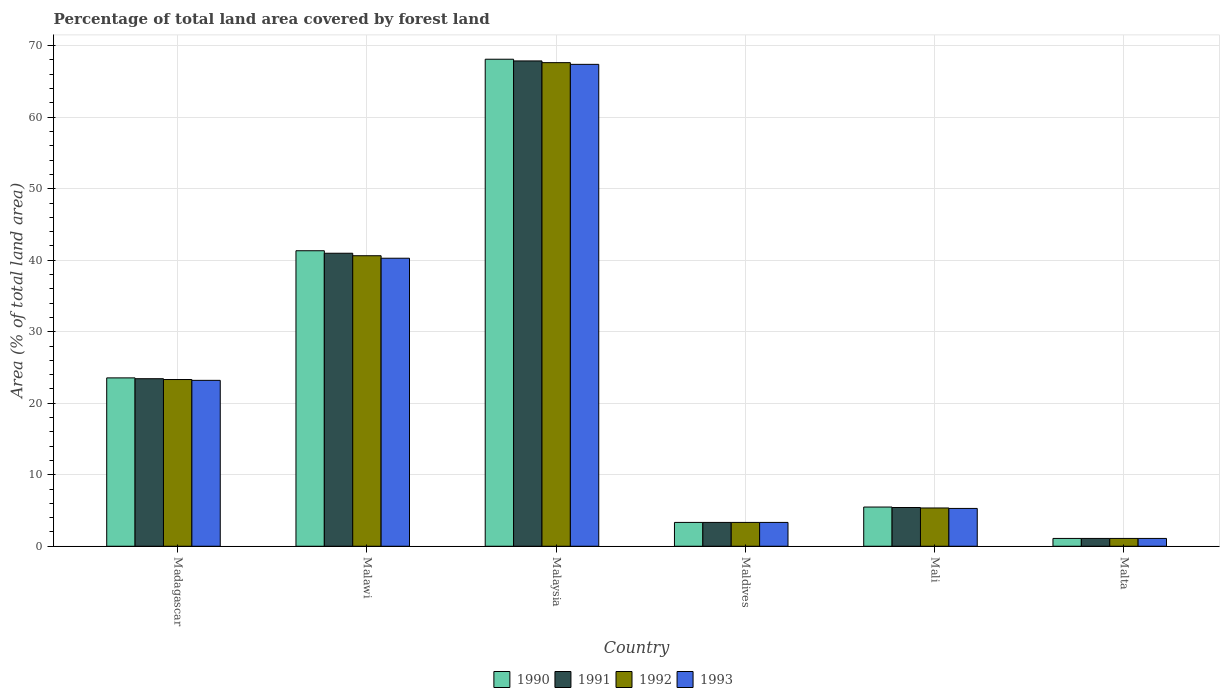How many different coloured bars are there?
Provide a short and direct response. 4. Are the number of bars on each tick of the X-axis equal?
Your answer should be compact. Yes. How many bars are there on the 4th tick from the left?
Keep it short and to the point. 4. What is the label of the 1st group of bars from the left?
Give a very brief answer. Madagascar. In how many cases, is the number of bars for a given country not equal to the number of legend labels?
Make the answer very short. 0. What is the percentage of forest land in 1990 in Malaysia?
Your answer should be compact. 68.11. Across all countries, what is the maximum percentage of forest land in 1993?
Offer a very short reply. 67.39. Across all countries, what is the minimum percentage of forest land in 1990?
Offer a terse response. 1.09. In which country was the percentage of forest land in 1993 maximum?
Provide a short and direct response. Malaysia. In which country was the percentage of forest land in 1990 minimum?
Your answer should be compact. Malta. What is the total percentage of forest land in 1992 in the graph?
Provide a succinct answer. 141.35. What is the difference between the percentage of forest land in 1992 in Malawi and that in Malaysia?
Offer a very short reply. -27. What is the difference between the percentage of forest land in 1991 in Madagascar and the percentage of forest land in 1993 in Malaysia?
Your answer should be compact. -43.96. What is the average percentage of forest land in 1990 per country?
Provide a short and direct response. 23.81. What is the difference between the percentage of forest land of/in 1990 and percentage of forest land of/in 1993 in Mali?
Offer a very short reply. 0.19. In how many countries, is the percentage of forest land in 1990 greater than 30 %?
Ensure brevity in your answer.  2. What is the ratio of the percentage of forest land in 1990 in Madagascar to that in Mali?
Provide a short and direct response. 4.29. What is the difference between the highest and the second highest percentage of forest land in 1993?
Offer a very short reply. -27.11. What is the difference between the highest and the lowest percentage of forest land in 1992?
Provide a succinct answer. 66.53. Is the sum of the percentage of forest land in 1990 in Malawi and Malta greater than the maximum percentage of forest land in 1992 across all countries?
Provide a succinct answer. No. What does the 2nd bar from the left in Malawi represents?
Offer a very short reply. 1991. How many countries are there in the graph?
Give a very brief answer. 6. What is the difference between two consecutive major ticks on the Y-axis?
Your answer should be compact. 10. Are the values on the major ticks of Y-axis written in scientific E-notation?
Offer a very short reply. No. Does the graph contain grids?
Provide a succinct answer. Yes. Where does the legend appear in the graph?
Provide a short and direct response. Bottom center. How are the legend labels stacked?
Ensure brevity in your answer.  Horizontal. What is the title of the graph?
Make the answer very short. Percentage of total land area covered by forest land. What is the label or title of the Y-axis?
Your answer should be very brief. Area (% of total land area). What is the Area (% of total land area) in 1990 in Madagascar?
Provide a succinct answer. 23.54. What is the Area (% of total land area) in 1991 in Madagascar?
Provide a short and direct response. 23.43. What is the Area (% of total land area) of 1992 in Madagascar?
Provide a short and direct response. 23.31. What is the Area (% of total land area) of 1993 in Madagascar?
Ensure brevity in your answer.  23.2. What is the Area (% of total land area) in 1990 in Malawi?
Offer a very short reply. 41.32. What is the Area (% of total land area) of 1991 in Malawi?
Make the answer very short. 40.97. What is the Area (% of total land area) in 1992 in Malawi?
Make the answer very short. 40.63. What is the Area (% of total land area) in 1993 in Malawi?
Give a very brief answer. 40.28. What is the Area (% of total land area) of 1990 in Malaysia?
Give a very brief answer. 68.11. What is the Area (% of total land area) of 1991 in Malaysia?
Make the answer very short. 67.87. What is the Area (% of total land area) of 1992 in Malaysia?
Give a very brief answer. 67.63. What is the Area (% of total land area) of 1993 in Malaysia?
Your answer should be very brief. 67.39. What is the Area (% of total land area) of 1990 in Maldives?
Offer a very short reply. 3.33. What is the Area (% of total land area) of 1991 in Maldives?
Keep it short and to the point. 3.33. What is the Area (% of total land area) of 1992 in Maldives?
Provide a short and direct response. 3.33. What is the Area (% of total land area) in 1993 in Maldives?
Keep it short and to the point. 3.33. What is the Area (% of total land area) in 1990 in Mali?
Your answer should be compact. 5.48. What is the Area (% of total land area) of 1991 in Mali?
Ensure brevity in your answer.  5.42. What is the Area (% of total land area) in 1992 in Mali?
Offer a terse response. 5.35. What is the Area (% of total land area) in 1993 in Mali?
Provide a short and direct response. 5.29. What is the Area (% of total land area) in 1990 in Malta?
Your answer should be compact. 1.09. What is the Area (% of total land area) in 1991 in Malta?
Offer a very short reply. 1.09. What is the Area (% of total land area) of 1992 in Malta?
Offer a terse response. 1.09. What is the Area (% of total land area) in 1993 in Malta?
Your answer should be compact. 1.09. Across all countries, what is the maximum Area (% of total land area) in 1990?
Your answer should be very brief. 68.11. Across all countries, what is the maximum Area (% of total land area) in 1991?
Your answer should be very brief. 67.87. Across all countries, what is the maximum Area (% of total land area) in 1992?
Offer a terse response. 67.63. Across all countries, what is the maximum Area (% of total land area) of 1993?
Offer a terse response. 67.39. Across all countries, what is the minimum Area (% of total land area) in 1990?
Offer a terse response. 1.09. Across all countries, what is the minimum Area (% of total land area) in 1991?
Offer a terse response. 1.09. Across all countries, what is the minimum Area (% of total land area) of 1992?
Make the answer very short. 1.09. Across all countries, what is the minimum Area (% of total land area) of 1993?
Offer a terse response. 1.09. What is the total Area (% of total land area) in 1990 in the graph?
Make the answer very short. 142.88. What is the total Area (% of total land area) of 1991 in the graph?
Provide a succinct answer. 142.12. What is the total Area (% of total land area) of 1992 in the graph?
Make the answer very short. 141.35. What is the total Area (% of total land area) in 1993 in the graph?
Your response must be concise. 140.58. What is the difference between the Area (% of total land area) in 1990 in Madagascar and that in Malawi?
Give a very brief answer. -17.78. What is the difference between the Area (% of total land area) of 1991 in Madagascar and that in Malawi?
Your answer should be compact. -17.55. What is the difference between the Area (% of total land area) of 1992 in Madagascar and that in Malawi?
Your response must be concise. -17.31. What is the difference between the Area (% of total land area) of 1993 in Madagascar and that in Malawi?
Your answer should be very brief. -17.08. What is the difference between the Area (% of total land area) of 1990 in Madagascar and that in Malaysia?
Offer a very short reply. -44.56. What is the difference between the Area (% of total land area) of 1991 in Madagascar and that in Malaysia?
Offer a very short reply. -44.44. What is the difference between the Area (% of total land area) of 1992 in Madagascar and that in Malaysia?
Your response must be concise. -44.31. What is the difference between the Area (% of total land area) of 1993 in Madagascar and that in Malaysia?
Ensure brevity in your answer.  -44.19. What is the difference between the Area (% of total land area) in 1990 in Madagascar and that in Maldives?
Offer a very short reply. 20.21. What is the difference between the Area (% of total land area) of 1991 in Madagascar and that in Maldives?
Make the answer very short. 20.1. What is the difference between the Area (% of total land area) in 1992 in Madagascar and that in Maldives?
Your response must be concise. 19.98. What is the difference between the Area (% of total land area) in 1993 in Madagascar and that in Maldives?
Your answer should be compact. 19.87. What is the difference between the Area (% of total land area) of 1990 in Madagascar and that in Mali?
Offer a very short reply. 18.06. What is the difference between the Area (% of total land area) of 1991 in Madagascar and that in Mali?
Give a very brief answer. 18.01. What is the difference between the Area (% of total land area) in 1992 in Madagascar and that in Mali?
Give a very brief answer. 17.96. What is the difference between the Area (% of total land area) of 1993 in Madagascar and that in Mali?
Give a very brief answer. 17.91. What is the difference between the Area (% of total land area) of 1990 in Madagascar and that in Malta?
Make the answer very short. 22.45. What is the difference between the Area (% of total land area) of 1991 in Madagascar and that in Malta?
Offer a terse response. 22.34. What is the difference between the Area (% of total land area) in 1992 in Madagascar and that in Malta?
Make the answer very short. 22.22. What is the difference between the Area (% of total land area) of 1993 in Madagascar and that in Malta?
Make the answer very short. 22.11. What is the difference between the Area (% of total land area) in 1990 in Malawi and that in Malaysia?
Your answer should be compact. -26.78. What is the difference between the Area (% of total land area) of 1991 in Malawi and that in Malaysia?
Your answer should be very brief. -26.89. What is the difference between the Area (% of total land area) in 1992 in Malawi and that in Malaysia?
Offer a very short reply. -27. What is the difference between the Area (% of total land area) in 1993 in Malawi and that in Malaysia?
Offer a very short reply. -27.11. What is the difference between the Area (% of total land area) of 1990 in Malawi and that in Maldives?
Ensure brevity in your answer.  37.99. What is the difference between the Area (% of total land area) in 1991 in Malawi and that in Maldives?
Make the answer very short. 37.64. What is the difference between the Area (% of total land area) of 1992 in Malawi and that in Maldives?
Offer a very short reply. 37.29. What is the difference between the Area (% of total land area) of 1993 in Malawi and that in Maldives?
Your answer should be very brief. 36.94. What is the difference between the Area (% of total land area) in 1990 in Malawi and that in Mali?
Give a very brief answer. 35.84. What is the difference between the Area (% of total land area) of 1991 in Malawi and that in Mali?
Make the answer very short. 35.56. What is the difference between the Area (% of total land area) of 1992 in Malawi and that in Mali?
Your response must be concise. 35.27. What is the difference between the Area (% of total land area) of 1993 in Malawi and that in Mali?
Offer a terse response. 34.99. What is the difference between the Area (% of total land area) of 1990 in Malawi and that in Malta?
Offer a terse response. 40.23. What is the difference between the Area (% of total land area) in 1991 in Malawi and that in Malta?
Keep it short and to the point. 39.88. What is the difference between the Area (% of total land area) of 1992 in Malawi and that in Malta?
Give a very brief answer. 39.53. What is the difference between the Area (% of total land area) of 1993 in Malawi and that in Malta?
Your response must be concise. 39.18. What is the difference between the Area (% of total land area) in 1990 in Malaysia and that in Maldives?
Offer a terse response. 64.77. What is the difference between the Area (% of total land area) of 1991 in Malaysia and that in Maldives?
Keep it short and to the point. 64.53. What is the difference between the Area (% of total land area) in 1992 in Malaysia and that in Maldives?
Make the answer very short. 64.29. What is the difference between the Area (% of total land area) of 1993 in Malaysia and that in Maldives?
Offer a very short reply. 64.06. What is the difference between the Area (% of total land area) in 1990 in Malaysia and that in Mali?
Ensure brevity in your answer.  62.62. What is the difference between the Area (% of total land area) in 1991 in Malaysia and that in Mali?
Offer a very short reply. 62.45. What is the difference between the Area (% of total land area) in 1992 in Malaysia and that in Mali?
Provide a short and direct response. 62.27. What is the difference between the Area (% of total land area) in 1993 in Malaysia and that in Mali?
Give a very brief answer. 62.1. What is the difference between the Area (% of total land area) in 1990 in Malaysia and that in Malta?
Your response must be concise. 67.01. What is the difference between the Area (% of total land area) in 1991 in Malaysia and that in Malta?
Make the answer very short. 66.77. What is the difference between the Area (% of total land area) of 1992 in Malaysia and that in Malta?
Give a very brief answer. 66.53. What is the difference between the Area (% of total land area) of 1993 in Malaysia and that in Malta?
Your answer should be very brief. 66.29. What is the difference between the Area (% of total land area) in 1990 in Maldives and that in Mali?
Provide a short and direct response. -2.15. What is the difference between the Area (% of total land area) in 1991 in Maldives and that in Mali?
Make the answer very short. -2.08. What is the difference between the Area (% of total land area) of 1992 in Maldives and that in Mali?
Keep it short and to the point. -2.02. What is the difference between the Area (% of total land area) of 1993 in Maldives and that in Mali?
Give a very brief answer. -1.96. What is the difference between the Area (% of total land area) in 1990 in Maldives and that in Malta?
Offer a very short reply. 2.24. What is the difference between the Area (% of total land area) of 1991 in Maldives and that in Malta?
Make the answer very short. 2.24. What is the difference between the Area (% of total land area) in 1992 in Maldives and that in Malta?
Your response must be concise. 2.24. What is the difference between the Area (% of total land area) of 1993 in Maldives and that in Malta?
Make the answer very short. 2.24. What is the difference between the Area (% of total land area) of 1990 in Mali and that in Malta?
Give a very brief answer. 4.39. What is the difference between the Area (% of total land area) in 1991 in Mali and that in Malta?
Give a very brief answer. 4.32. What is the difference between the Area (% of total land area) of 1992 in Mali and that in Malta?
Keep it short and to the point. 4.26. What is the difference between the Area (% of total land area) of 1993 in Mali and that in Malta?
Offer a very short reply. 4.19. What is the difference between the Area (% of total land area) of 1990 in Madagascar and the Area (% of total land area) of 1991 in Malawi?
Offer a terse response. -17.43. What is the difference between the Area (% of total land area) of 1990 in Madagascar and the Area (% of total land area) of 1992 in Malawi?
Your response must be concise. -17.08. What is the difference between the Area (% of total land area) in 1990 in Madagascar and the Area (% of total land area) in 1993 in Malawi?
Provide a succinct answer. -16.73. What is the difference between the Area (% of total land area) in 1991 in Madagascar and the Area (% of total land area) in 1992 in Malawi?
Your response must be concise. -17.2. What is the difference between the Area (% of total land area) of 1991 in Madagascar and the Area (% of total land area) of 1993 in Malawi?
Ensure brevity in your answer.  -16.85. What is the difference between the Area (% of total land area) in 1992 in Madagascar and the Area (% of total land area) in 1993 in Malawi?
Your answer should be very brief. -16.96. What is the difference between the Area (% of total land area) in 1990 in Madagascar and the Area (% of total land area) in 1991 in Malaysia?
Your answer should be compact. -44.32. What is the difference between the Area (% of total land area) of 1990 in Madagascar and the Area (% of total land area) of 1992 in Malaysia?
Keep it short and to the point. -44.08. What is the difference between the Area (% of total land area) of 1990 in Madagascar and the Area (% of total land area) of 1993 in Malaysia?
Your answer should be very brief. -43.84. What is the difference between the Area (% of total land area) in 1991 in Madagascar and the Area (% of total land area) in 1992 in Malaysia?
Your response must be concise. -44.2. What is the difference between the Area (% of total land area) of 1991 in Madagascar and the Area (% of total land area) of 1993 in Malaysia?
Your answer should be very brief. -43.96. What is the difference between the Area (% of total land area) of 1992 in Madagascar and the Area (% of total land area) of 1993 in Malaysia?
Keep it short and to the point. -44.07. What is the difference between the Area (% of total land area) in 1990 in Madagascar and the Area (% of total land area) in 1991 in Maldives?
Give a very brief answer. 20.21. What is the difference between the Area (% of total land area) of 1990 in Madagascar and the Area (% of total land area) of 1992 in Maldives?
Provide a short and direct response. 20.21. What is the difference between the Area (% of total land area) in 1990 in Madagascar and the Area (% of total land area) in 1993 in Maldives?
Your response must be concise. 20.21. What is the difference between the Area (% of total land area) in 1991 in Madagascar and the Area (% of total land area) in 1992 in Maldives?
Keep it short and to the point. 20.1. What is the difference between the Area (% of total land area) of 1991 in Madagascar and the Area (% of total land area) of 1993 in Maldives?
Keep it short and to the point. 20.1. What is the difference between the Area (% of total land area) of 1992 in Madagascar and the Area (% of total land area) of 1993 in Maldives?
Keep it short and to the point. 19.98. What is the difference between the Area (% of total land area) of 1990 in Madagascar and the Area (% of total land area) of 1991 in Mali?
Make the answer very short. 18.13. What is the difference between the Area (% of total land area) of 1990 in Madagascar and the Area (% of total land area) of 1992 in Mali?
Your response must be concise. 18.19. What is the difference between the Area (% of total land area) of 1990 in Madagascar and the Area (% of total land area) of 1993 in Mali?
Keep it short and to the point. 18.26. What is the difference between the Area (% of total land area) in 1991 in Madagascar and the Area (% of total land area) in 1992 in Mali?
Provide a succinct answer. 18.08. What is the difference between the Area (% of total land area) of 1991 in Madagascar and the Area (% of total land area) of 1993 in Mali?
Give a very brief answer. 18.14. What is the difference between the Area (% of total land area) of 1992 in Madagascar and the Area (% of total land area) of 1993 in Mali?
Your answer should be very brief. 18.03. What is the difference between the Area (% of total land area) of 1990 in Madagascar and the Area (% of total land area) of 1991 in Malta?
Provide a short and direct response. 22.45. What is the difference between the Area (% of total land area) in 1990 in Madagascar and the Area (% of total land area) in 1992 in Malta?
Give a very brief answer. 22.45. What is the difference between the Area (% of total land area) of 1990 in Madagascar and the Area (% of total land area) of 1993 in Malta?
Your response must be concise. 22.45. What is the difference between the Area (% of total land area) in 1991 in Madagascar and the Area (% of total land area) in 1992 in Malta?
Your answer should be compact. 22.34. What is the difference between the Area (% of total land area) in 1991 in Madagascar and the Area (% of total land area) in 1993 in Malta?
Ensure brevity in your answer.  22.34. What is the difference between the Area (% of total land area) in 1992 in Madagascar and the Area (% of total land area) in 1993 in Malta?
Your answer should be very brief. 22.22. What is the difference between the Area (% of total land area) in 1990 in Malawi and the Area (% of total land area) in 1991 in Malaysia?
Provide a short and direct response. -26.54. What is the difference between the Area (% of total land area) in 1990 in Malawi and the Area (% of total land area) in 1992 in Malaysia?
Your answer should be compact. -26.3. What is the difference between the Area (% of total land area) of 1990 in Malawi and the Area (% of total land area) of 1993 in Malaysia?
Offer a terse response. -26.06. What is the difference between the Area (% of total land area) in 1991 in Malawi and the Area (% of total land area) in 1992 in Malaysia?
Your answer should be very brief. -26.65. What is the difference between the Area (% of total land area) of 1991 in Malawi and the Area (% of total land area) of 1993 in Malaysia?
Your response must be concise. -26.41. What is the difference between the Area (% of total land area) in 1992 in Malawi and the Area (% of total land area) in 1993 in Malaysia?
Ensure brevity in your answer.  -26.76. What is the difference between the Area (% of total land area) of 1990 in Malawi and the Area (% of total land area) of 1991 in Maldives?
Offer a very short reply. 37.99. What is the difference between the Area (% of total land area) of 1990 in Malawi and the Area (% of total land area) of 1992 in Maldives?
Provide a short and direct response. 37.99. What is the difference between the Area (% of total land area) in 1990 in Malawi and the Area (% of total land area) in 1993 in Maldives?
Keep it short and to the point. 37.99. What is the difference between the Area (% of total land area) in 1991 in Malawi and the Area (% of total land area) in 1992 in Maldives?
Ensure brevity in your answer.  37.64. What is the difference between the Area (% of total land area) of 1991 in Malawi and the Area (% of total land area) of 1993 in Maldives?
Your response must be concise. 37.64. What is the difference between the Area (% of total land area) in 1992 in Malawi and the Area (% of total land area) in 1993 in Maldives?
Give a very brief answer. 37.29. What is the difference between the Area (% of total land area) of 1990 in Malawi and the Area (% of total land area) of 1991 in Mali?
Offer a terse response. 35.91. What is the difference between the Area (% of total land area) in 1990 in Malawi and the Area (% of total land area) in 1992 in Mali?
Your answer should be very brief. 35.97. What is the difference between the Area (% of total land area) of 1990 in Malawi and the Area (% of total land area) of 1993 in Mali?
Keep it short and to the point. 36.04. What is the difference between the Area (% of total land area) of 1991 in Malawi and the Area (% of total land area) of 1992 in Mali?
Your response must be concise. 35.62. What is the difference between the Area (% of total land area) in 1991 in Malawi and the Area (% of total land area) in 1993 in Mali?
Offer a very short reply. 35.69. What is the difference between the Area (% of total land area) of 1992 in Malawi and the Area (% of total land area) of 1993 in Mali?
Provide a succinct answer. 35.34. What is the difference between the Area (% of total land area) in 1990 in Malawi and the Area (% of total land area) in 1991 in Malta?
Offer a very short reply. 40.23. What is the difference between the Area (% of total land area) of 1990 in Malawi and the Area (% of total land area) of 1992 in Malta?
Keep it short and to the point. 40.23. What is the difference between the Area (% of total land area) of 1990 in Malawi and the Area (% of total land area) of 1993 in Malta?
Make the answer very short. 40.23. What is the difference between the Area (% of total land area) of 1991 in Malawi and the Area (% of total land area) of 1992 in Malta?
Give a very brief answer. 39.88. What is the difference between the Area (% of total land area) of 1991 in Malawi and the Area (% of total land area) of 1993 in Malta?
Offer a very short reply. 39.88. What is the difference between the Area (% of total land area) in 1992 in Malawi and the Area (% of total land area) in 1993 in Malta?
Your response must be concise. 39.53. What is the difference between the Area (% of total land area) of 1990 in Malaysia and the Area (% of total land area) of 1991 in Maldives?
Make the answer very short. 64.77. What is the difference between the Area (% of total land area) of 1990 in Malaysia and the Area (% of total land area) of 1992 in Maldives?
Give a very brief answer. 64.77. What is the difference between the Area (% of total land area) in 1990 in Malaysia and the Area (% of total land area) in 1993 in Maldives?
Your answer should be compact. 64.77. What is the difference between the Area (% of total land area) of 1991 in Malaysia and the Area (% of total land area) of 1992 in Maldives?
Keep it short and to the point. 64.53. What is the difference between the Area (% of total land area) in 1991 in Malaysia and the Area (% of total land area) in 1993 in Maldives?
Your answer should be very brief. 64.53. What is the difference between the Area (% of total land area) in 1992 in Malaysia and the Area (% of total land area) in 1993 in Maldives?
Your response must be concise. 64.29. What is the difference between the Area (% of total land area) of 1990 in Malaysia and the Area (% of total land area) of 1991 in Mali?
Keep it short and to the point. 62.69. What is the difference between the Area (% of total land area) in 1990 in Malaysia and the Area (% of total land area) in 1992 in Mali?
Keep it short and to the point. 62.75. What is the difference between the Area (% of total land area) in 1990 in Malaysia and the Area (% of total land area) in 1993 in Mali?
Provide a short and direct response. 62.82. What is the difference between the Area (% of total land area) in 1991 in Malaysia and the Area (% of total land area) in 1992 in Mali?
Give a very brief answer. 62.51. What is the difference between the Area (% of total land area) in 1991 in Malaysia and the Area (% of total land area) in 1993 in Mali?
Offer a very short reply. 62.58. What is the difference between the Area (% of total land area) in 1992 in Malaysia and the Area (% of total land area) in 1993 in Mali?
Make the answer very short. 62.34. What is the difference between the Area (% of total land area) in 1990 in Malaysia and the Area (% of total land area) in 1991 in Malta?
Provide a succinct answer. 67.01. What is the difference between the Area (% of total land area) in 1990 in Malaysia and the Area (% of total land area) in 1992 in Malta?
Your answer should be very brief. 67.01. What is the difference between the Area (% of total land area) of 1990 in Malaysia and the Area (% of total land area) of 1993 in Malta?
Provide a succinct answer. 67.01. What is the difference between the Area (% of total land area) of 1991 in Malaysia and the Area (% of total land area) of 1992 in Malta?
Your answer should be compact. 66.77. What is the difference between the Area (% of total land area) of 1991 in Malaysia and the Area (% of total land area) of 1993 in Malta?
Provide a short and direct response. 66.77. What is the difference between the Area (% of total land area) of 1992 in Malaysia and the Area (% of total land area) of 1993 in Malta?
Keep it short and to the point. 66.53. What is the difference between the Area (% of total land area) of 1990 in Maldives and the Area (% of total land area) of 1991 in Mali?
Offer a very short reply. -2.08. What is the difference between the Area (% of total land area) in 1990 in Maldives and the Area (% of total land area) in 1992 in Mali?
Your answer should be compact. -2.02. What is the difference between the Area (% of total land area) in 1990 in Maldives and the Area (% of total land area) in 1993 in Mali?
Make the answer very short. -1.96. What is the difference between the Area (% of total land area) of 1991 in Maldives and the Area (% of total land area) of 1992 in Mali?
Your response must be concise. -2.02. What is the difference between the Area (% of total land area) in 1991 in Maldives and the Area (% of total land area) in 1993 in Mali?
Your response must be concise. -1.96. What is the difference between the Area (% of total land area) of 1992 in Maldives and the Area (% of total land area) of 1993 in Mali?
Your answer should be compact. -1.96. What is the difference between the Area (% of total land area) of 1990 in Maldives and the Area (% of total land area) of 1991 in Malta?
Your answer should be very brief. 2.24. What is the difference between the Area (% of total land area) in 1990 in Maldives and the Area (% of total land area) in 1992 in Malta?
Provide a succinct answer. 2.24. What is the difference between the Area (% of total land area) in 1990 in Maldives and the Area (% of total land area) in 1993 in Malta?
Make the answer very short. 2.24. What is the difference between the Area (% of total land area) in 1991 in Maldives and the Area (% of total land area) in 1992 in Malta?
Your response must be concise. 2.24. What is the difference between the Area (% of total land area) of 1991 in Maldives and the Area (% of total land area) of 1993 in Malta?
Make the answer very short. 2.24. What is the difference between the Area (% of total land area) of 1992 in Maldives and the Area (% of total land area) of 1993 in Malta?
Keep it short and to the point. 2.24. What is the difference between the Area (% of total land area) of 1990 in Mali and the Area (% of total land area) of 1991 in Malta?
Keep it short and to the point. 4.39. What is the difference between the Area (% of total land area) in 1990 in Mali and the Area (% of total land area) in 1992 in Malta?
Your answer should be very brief. 4.39. What is the difference between the Area (% of total land area) in 1990 in Mali and the Area (% of total land area) in 1993 in Malta?
Provide a short and direct response. 4.39. What is the difference between the Area (% of total land area) of 1991 in Mali and the Area (% of total land area) of 1992 in Malta?
Your response must be concise. 4.32. What is the difference between the Area (% of total land area) in 1991 in Mali and the Area (% of total land area) in 1993 in Malta?
Your response must be concise. 4.32. What is the difference between the Area (% of total land area) of 1992 in Mali and the Area (% of total land area) of 1993 in Malta?
Keep it short and to the point. 4.26. What is the average Area (% of total land area) in 1990 per country?
Your answer should be very brief. 23.81. What is the average Area (% of total land area) in 1991 per country?
Your answer should be very brief. 23.69. What is the average Area (% of total land area) in 1992 per country?
Offer a very short reply. 23.56. What is the average Area (% of total land area) in 1993 per country?
Your answer should be compact. 23.43. What is the difference between the Area (% of total land area) in 1990 and Area (% of total land area) in 1991 in Madagascar?
Your answer should be compact. 0.12. What is the difference between the Area (% of total land area) of 1990 and Area (% of total land area) of 1992 in Madagascar?
Provide a succinct answer. 0.23. What is the difference between the Area (% of total land area) in 1990 and Area (% of total land area) in 1993 in Madagascar?
Provide a succinct answer. 0.35. What is the difference between the Area (% of total land area) in 1991 and Area (% of total land area) in 1992 in Madagascar?
Your response must be concise. 0.12. What is the difference between the Area (% of total land area) of 1991 and Area (% of total land area) of 1993 in Madagascar?
Keep it short and to the point. 0.23. What is the difference between the Area (% of total land area) of 1992 and Area (% of total land area) of 1993 in Madagascar?
Your answer should be very brief. 0.12. What is the difference between the Area (% of total land area) of 1990 and Area (% of total land area) of 1991 in Malawi?
Provide a short and direct response. 0.35. What is the difference between the Area (% of total land area) in 1990 and Area (% of total land area) in 1992 in Malawi?
Make the answer very short. 0.7. What is the difference between the Area (% of total land area) of 1990 and Area (% of total land area) of 1993 in Malawi?
Ensure brevity in your answer.  1.05. What is the difference between the Area (% of total land area) of 1991 and Area (% of total land area) of 1992 in Malawi?
Make the answer very short. 0.35. What is the difference between the Area (% of total land area) in 1991 and Area (% of total land area) in 1993 in Malawi?
Provide a succinct answer. 0.7. What is the difference between the Area (% of total land area) of 1992 and Area (% of total land area) of 1993 in Malawi?
Offer a very short reply. 0.35. What is the difference between the Area (% of total land area) in 1990 and Area (% of total land area) in 1991 in Malaysia?
Keep it short and to the point. 0.24. What is the difference between the Area (% of total land area) of 1990 and Area (% of total land area) of 1992 in Malaysia?
Your answer should be very brief. 0.48. What is the difference between the Area (% of total land area) in 1990 and Area (% of total land area) in 1993 in Malaysia?
Your answer should be very brief. 0.72. What is the difference between the Area (% of total land area) of 1991 and Area (% of total land area) of 1992 in Malaysia?
Make the answer very short. 0.24. What is the difference between the Area (% of total land area) in 1991 and Area (% of total land area) in 1993 in Malaysia?
Your answer should be very brief. 0.48. What is the difference between the Area (% of total land area) in 1992 and Area (% of total land area) in 1993 in Malaysia?
Give a very brief answer. 0.24. What is the difference between the Area (% of total land area) of 1990 and Area (% of total land area) of 1991 in Maldives?
Ensure brevity in your answer.  0. What is the difference between the Area (% of total land area) of 1990 and Area (% of total land area) of 1992 in Maldives?
Keep it short and to the point. 0. What is the difference between the Area (% of total land area) of 1990 and Area (% of total land area) of 1993 in Maldives?
Your response must be concise. 0. What is the difference between the Area (% of total land area) of 1991 and Area (% of total land area) of 1992 in Maldives?
Keep it short and to the point. 0. What is the difference between the Area (% of total land area) of 1991 and Area (% of total land area) of 1993 in Maldives?
Keep it short and to the point. 0. What is the difference between the Area (% of total land area) in 1990 and Area (% of total land area) in 1991 in Mali?
Provide a succinct answer. 0.06. What is the difference between the Area (% of total land area) in 1990 and Area (% of total land area) in 1992 in Mali?
Provide a short and direct response. 0.13. What is the difference between the Area (% of total land area) of 1990 and Area (% of total land area) of 1993 in Mali?
Your answer should be very brief. 0.19. What is the difference between the Area (% of total land area) of 1991 and Area (% of total land area) of 1992 in Mali?
Give a very brief answer. 0.06. What is the difference between the Area (% of total land area) of 1991 and Area (% of total land area) of 1993 in Mali?
Your answer should be very brief. 0.13. What is the difference between the Area (% of total land area) in 1992 and Area (% of total land area) in 1993 in Mali?
Offer a very short reply. 0.06. What is the difference between the Area (% of total land area) in 1990 and Area (% of total land area) in 1991 in Malta?
Your response must be concise. 0. What is the difference between the Area (% of total land area) in 1991 and Area (% of total land area) in 1992 in Malta?
Ensure brevity in your answer.  0. What is the ratio of the Area (% of total land area) of 1990 in Madagascar to that in Malawi?
Your answer should be compact. 0.57. What is the ratio of the Area (% of total land area) in 1991 in Madagascar to that in Malawi?
Your answer should be very brief. 0.57. What is the ratio of the Area (% of total land area) in 1992 in Madagascar to that in Malawi?
Ensure brevity in your answer.  0.57. What is the ratio of the Area (% of total land area) in 1993 in Madagascar to that in Malawi?
Keep it short and to the point. 0.58. What is the ratio of the Area (% of total land area) in 1990 in Madagascar to that in Malaysia?
Give a very brief answer. 0.35. What is the ratio of the Area (% of total land area) of 1991 in Madagascar to that in Malaysia?
Your answer should be compact. 0.35. What is the ratio of the Area (% of total land area) in 1992 in Madagascar to that in Malaysia?
Offer a very short reply. 0.34. What is the ratio of the Area (% of total land area) of 1993 in Madagascar to that in Malaysia?
Offer a very short reply. 0.34. What is the ratio of the Area (% of total land area) in 1990 in Madagascar to that in Maldives?
Provide a succinct answer. 7.06. What is the ratio of the Area (% of total land area) in 1991 in Madagascar to that in Maldives?
Your answer should be compact. 7.03. What is the ratio of the Area (% of total land area) of 1992 in Madagascar to that in Maldives?
Provide a short and direct response. 6.99. What is the ratio of the Area (% of total land area) of 1993 in Madagascar to that in Maldives?
Keep it short and to the point. 6.96. What is the ratio of the Area (% of total land area) of 1990 in Madagascar to that in Mali?
Your answer should be very brief. 4.29. What is the ratio of the Area (% of total land area) in 1991 in Madagascar to that in Mali?
Your response must be concise. 4.32. What is the ratio of the Area (% of total land area) of 1992 in Madagascar to that in Mali?
Give a very brief answer. 4.36. What is the ratio of the Area (% of total land area) in 1993 in Madagascar to that in Mali?
Give a very brief answer. 4.39. What is the ratio of the Area (% of total land area) in 1990 in Madagascar to that in Malta?
Make the answer very short. 21.53. What is the ratio of the Area (% of total land area) in 1991 in Madagascar to that in Malta?
Provide a short and direct response. 21.42. What is the ratio of the Area (% of total land area) in 1992 in Madagascar to that in Malta?
Offer a terse response. 21.32. What is the ratio of the Area (% of total land area) of 1993 in Madagascar to that in Malta?
Keep it short and to the point. 21.21. What is the ratio of the Area (% of total land area) in 1990 in Malawi to that in Malaysia?
Your response must be concise. 0.61. What is the ratio of the Area (% of total land area) of 1991 in Malawi to that in Malaysia?
Provide a short and direct response. 0.6. What is the ratio of the Area (% of total land area) of 1992 in Malawi to that in Malaysia?
Your answer should be very brief. 0.6. What is the ratio of the Area (% of total land area) in 1993 in Malawi to that in Malaysia?
Provide a short and direct response. 0.6. What is the ratio of the Area (% of total land area) in 1990 in Malawi to that in Maldives?
Ensure brevity in your answer.  12.4. What is the ratio of the Area (% of total land area) in 1991 in Malawi to that in Maldives?
Your answer should be very brief. 12.29. What is the ratio of the Area (% of total land area) of 1992 in Malawi to that in Maldives?
Offer a very short reply. 12.19. What is the ratio of the Area (% of total land area) in 1993 in Malawi to that in Maldives?
Your answer should be very brief. 12.08. What is the ratio of the Area (% of total land area) in 1990 in Malawi to that in Mali?
Your answer should be very brief. 7.54. What is the ratio of the Area (% of total land area) of 1991 in Malawi to that in Mali?
Make the answer very short. 7.56. What is the ratio of the Area (% of total land area) of 1992 in Malawi to that in Mali?
Your answer should be very brief. 7.59. What is the ratio of the Area (% of total land area) of 1993 in Malawi to that in Mali?
Make the answer very short. 7.62. What is the ratio of the Area (% of total land area) in 1990 in Malawi to that in Malta?
Ensure brevity in your answer.  37.78. What is the ratio of the Area (% of total land area) in 1991 in Malawi to that in Malta?
Provide a succinct answer. 37.46. What is the ratio of the Area (% of total land area) in 1992 in Malawi to that in Malta?
Ensure brevity in your answer.  37.14. What is the ratio of the Area (% of total land area) in 1993 in Malawi to that in Malta?
Give a very brief answer. 36.82. What is the ratio of the Area (% of total land area) of 1990 in Malaysia to that in Maldives?
Your answer should be compact. 20.43. What is the ratio of the Area (% of total land area) of 1991 in Malaysia to that in Maldives?
Offer a very short reply. 20.36. What is the ratio of the Area (% of total land area) in 1992 in Malaysia to that in Maldives?
Your response must be concise. 20.29. What is the ratio of the Area (% of total land area) of 1993 in Malaysia to that in Maldives?
Your response must be concise. 20.22. What is the ratio of the Area (% of total land area) of 1990 in Malaysia to that in Mali?
Your answer should be compact. 12.42. What is the ratio of the Area (% of total land area) in 1991 in Malaysia to that in Mali?
Ensure brevity in your answer.  12.53. What is the ratio of the Area (% of total land area) in 1992 in Malaysia to that in Mali?
Your answer should be very brief. 12.63. What is the ratio of the Area (% of total land area) of 1993 in Malaysia to that in Mali?
Give a very brief answer. 12.74. What is the ratio of the Area (% of total land area) of 1990 in Malaysia to that in Malta?
Ensure brevity in your answer.  62.27. What is the ratio of the Area (% of total land area) in 1991 in Malaysia to that in Malta?
Your answer should be very brief. 62.05. What is the ratio of the Area (% of total land area) of 1992 in Malaysia to that in Malta?
Offer a very short reply. 61.83. What is the ratio of the Area (% of total land area) of 1993 in Malaysia to that in Malta?
Your response must be concise. 61.61. What is the ratio of the Area (% of total land area) in 1990 in Maldives to that in Mali?
Your answer should be very brief. 0.61. What is the ratio of the Area (% of total land area) in 1991 in Maldives to that in Mali?
Give a very brief answer. 0.62. What is the ratio of the Area (% of total land area) of 1992 in Maldives to that in Mali?
Ensure brevity in your answer.  0.62. What is the ratio of the Area (% of total land area) in 1993 in Maldives to that in Mali?
Your answer should be very brief. 0.63. What is the ratio of the Area (% of total land area) of 1990 in Maldives to that in Malta?
Provide a succinct answer. 3.05. What is the ratio of the Area (% of total land area) of 1991 in Maldives to that in Malta?
Your answer should be very brief. 3.05. What is the ratio of the Area (% of total land area) in 1992 in Maldives to that in Malta?
Keep it short and to the point. 3.05. What is the ratio of the Area (% of total land area) in 1993 in Maldives to that in Malta?
Give a very brief answer. 3.05. What is the ratio of the Area (% of total land area) of 1990 in Mali to that in Malta?
Make the answer very short. 5.01. What is the ratio of the Area (% of total land area) in 1991 in Mali to that in Malta?
Provide a short and direct response. 4.95. What is the ratio of the Area (% of total land area) in 1992 in Mali to that in Malta?
Your response must be concise. 4.89. What is the ratio of the Area (% of total land area) in 1993 in Mali to that in Malta?
Make the answer very short. 4.84. What is the difference between the highest and the second highest Area (% of total land area) of 1990?
Your answer should be compact. 26.78. What is the difference between the highest and the second highest Area (% of total land area) in 1991?
Make the answer very short. 26.89. What is the difference between the highest and the second highest Area (% of total land area) in 1992?
Offer a very short reply. 27. What is the difference between the highest and the second highest Area (% of total land area) in 1993?
Offer a very short reply. 27.11. What is the difference between the highest and the lowest Area (% of total land area) in 1990?
Keep it short and to the point. 67.01. What is the difference between the highest and the lowest Area (% of total land area) in 1991?
Provide a short and direct response. 66.77. What is the difference between the highest and the lowest Area (% of total land area) of 1992?
Your answer should be compact. 66.53. What is the difference between the highest and the lowest Area (% of total land area) of 1993?
Your answer should be very brief. 66.29. 